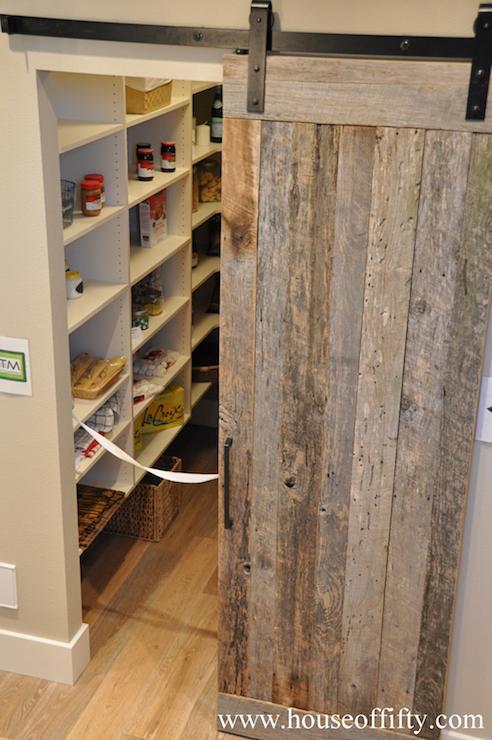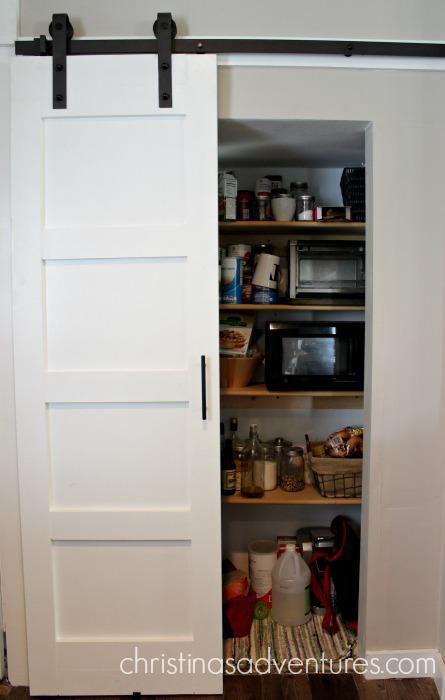The first image is the image on the left, the second image is the image on the right. For the images shown, is this caption "The left and right image contains the same number of hanging doors." true? Answer yes or no. Yes. The first image is the image on the left, the second image is the image on the right. Considering the images on both sides, is "One image shows white barn-style double doors that slide on an overhead black bar, and the doors are open revealing filled shelves." valid? Answer yes or no. No. 